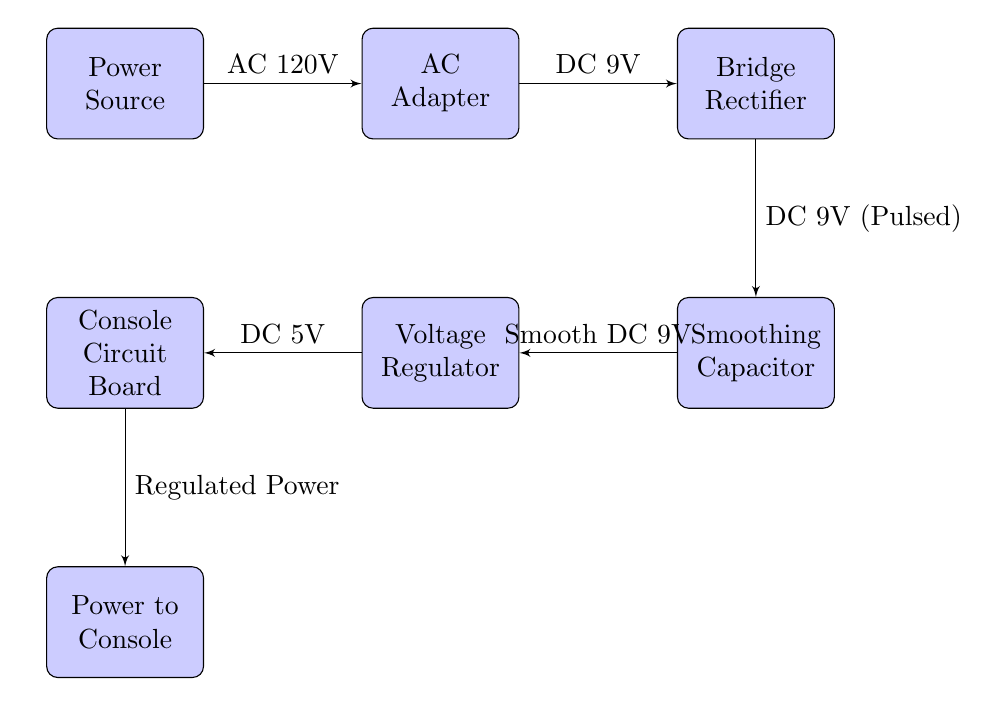What is the input voltage from the power source? The diagram shows that the power source delivers an input of AC 120V to the AC adapter.
Answer: AC 120V What type of adapter is used in the diagram? The diagram specifically labels the second block as "AC Adapter," indicating this is the type of adapter used in the process.
Answer: AC Adapter How many main blocks are present in the diagram? Counting the blocks in the diagram reveals a total of six distinct blocks: Power Source, AC Adapter, Bridge Rectifier, Smoothing Capacitor, Voltage Regulator, and Console Circuit Board.
Answer: Six What is the voltage output of the voltage regulator? The output label connected to the voltage regulator indicates that it delivers DC 5V to the console circuit board.
Answer: DC 5V What type of current does the bridge rectifier convert the input into? The connection from the bridge rectifier to the smoothing capacitor shows that it outputs DC 9V (Pulsed), indicating the type of current after conversion.
Answer: DC 9V (Pulsed) Describe the transition from the smoothing capacitor to the voltage regulator. The smoothing capacitor transforms the DC 9V (Pulsed) into Smooth DC 9V before sending it to the voltage regulator, which is a vital part of the power supply process.
Answer: Smooth DC 9V What is the main purpose of the voltage regulator in this diagram? The diagram indicates that the voltage regulator adjusts the voltage to an appropriate level, providing DC 5V to the console circuit board.
Answer: Regulate voltage What does the console circuit board receive as power input? The diagram clearly shows that the console circuit board is supplied with regulated power from the voltage regulator, specifically indicating DC 5V.
Answer: Regulated Power 